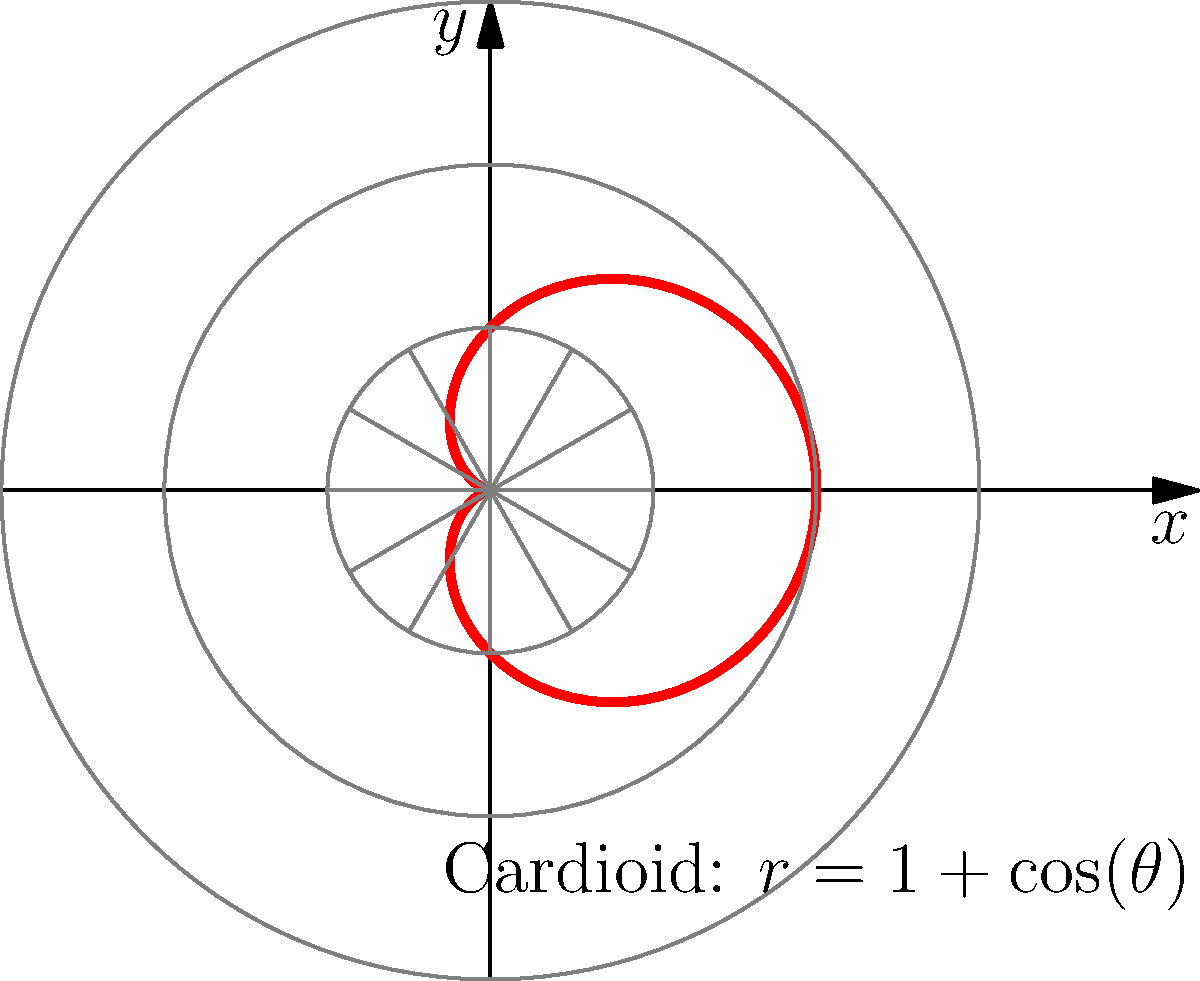In the context of sound wave patterns, the cardioid shape shown in the polar graph is often associated with the directional sensitivity of certain microphones. How does the equation $r = 1 + \cos(\theta)$ relate to the flow and rhythm of Big Pun's lyrical style? To understand the connection between the cardioid equation and Big Pun's lyrical style, let's break it down step-by-step:

1. The cardioid equation $r = 1 + \cos(\theta)$ represents a heart-shaped curve in polar coordinates.

2. In the context of microphones, this shape represents a directional pickup pattern, where sensitivity is highest in front and lowest at the back.

3. Big Pun's lyrical style is known for its:
   a) Precise directional flow, much like the cardioid's focused sensitivity
   b) Rhythmic patterns that oscillate between strong (1) and weaker (cos(θ)) elements

4. The constant term (1) in the equation represents Big Pun's consistent baseline flow, always present in his verses.

5. The $\cos(\theta)$ term represents the periodic variation in his rhyme schemes and wordplay, creating a dynamic rhythm.

6. As θ varies from 0 to 2π, the radius r changes smoothly, similar to how Big Pun transitions between different rhyme patterns seamlessly.

7. The heart shape formed by the equation mirrors the emotional depth and passion often present in Big Pun's lyrics.

8. Just as the cardioid has a clear front-back asymmetry, Big Pun's verses often have a distinct structure with powerful openings and impactful closings.

9. The continuous nature of the curve reflects the fluidity of Big Pun's delivery, with no abrupt changes in his flow.

10. The mathematical precision of the cardioid equation parallels the technical precision in Big Pun's complex rhyme schemes and multisyllabic rhymes.
Answer: The cardioid equation mirrors Big Pun's consistent baseline flow (1) and rhythmic variations (cos(θ)), representing his precise, dynamic, and seamlessly transitioning lyrical style. 